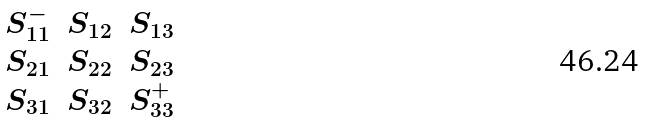Convert formula to latex. <formula><loc_0><loc_0><loc_500><loc_500>\begin{matrix} S ^ { - } _ { 1 1 } & S _ { 1 2 } & S _ { 1 3 } \\ S _ { 2 1 } & S _ { 2 2 } & S _ { 2 3 } \\ S _ { 3 1 } & S _ { 3 2 } & S ^ { + } _ { 3 3 } \end{matrix}</formula> 